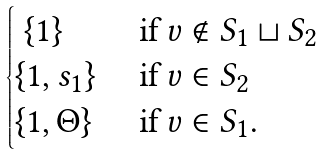<formula> <loc_0><loc_0><loc_500><loc_500>\begin{cases} \ \{ 1 \} & \text { if } v \notin S _ { 1 } \sqcup S _ { 2 } \\ \{ 1 , s _ { 1 } \} & \text { if } v \in S _ { 2 } \\ \{ 1 , \Theta \} & \text { if } v \in S _ { 1 } . \end{cases}</formula> 